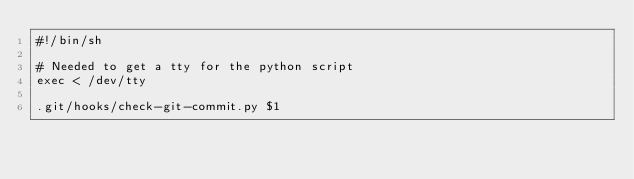<code> <loc_0><loc_0><loc_500><loc_500><_Bash_>#!/bin/sh

# Needed to get a tty for the python script
exec < /dev/tty

.git/hooks/check-git-commit.py $1</code> 